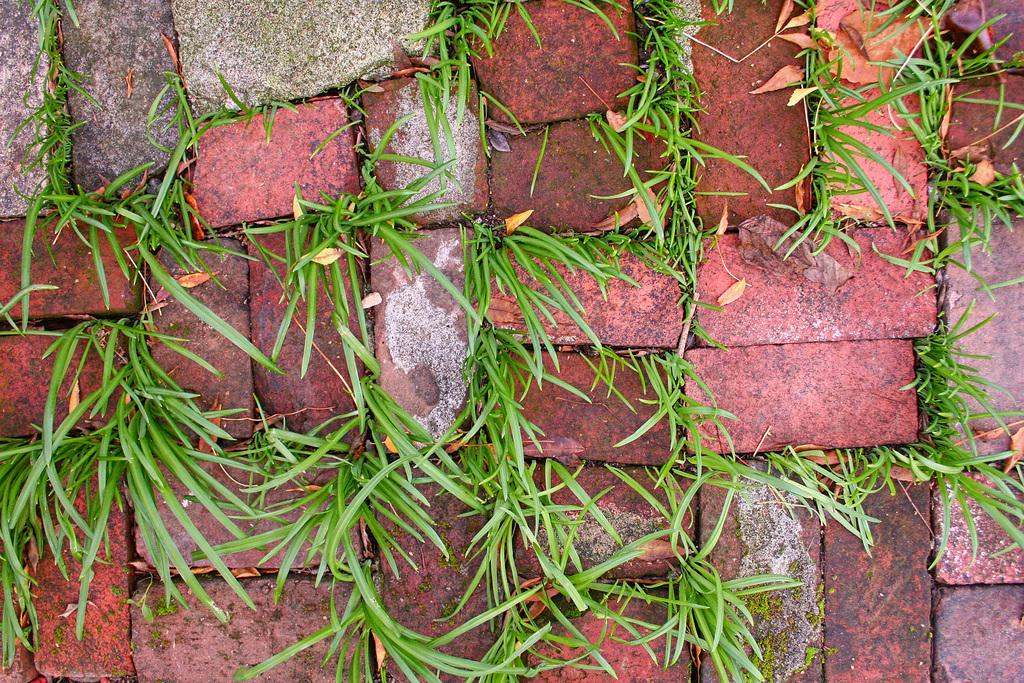What type of material is present in the image? There are bricks in the image. What natural elements can be seen in the image? There is grass and leaves visible in the image. Where is the goat located in the image? There is no goat present in the image. What type of lunchroom furniture can be seen in the image? There is no lunchroom furniture present in the image. 